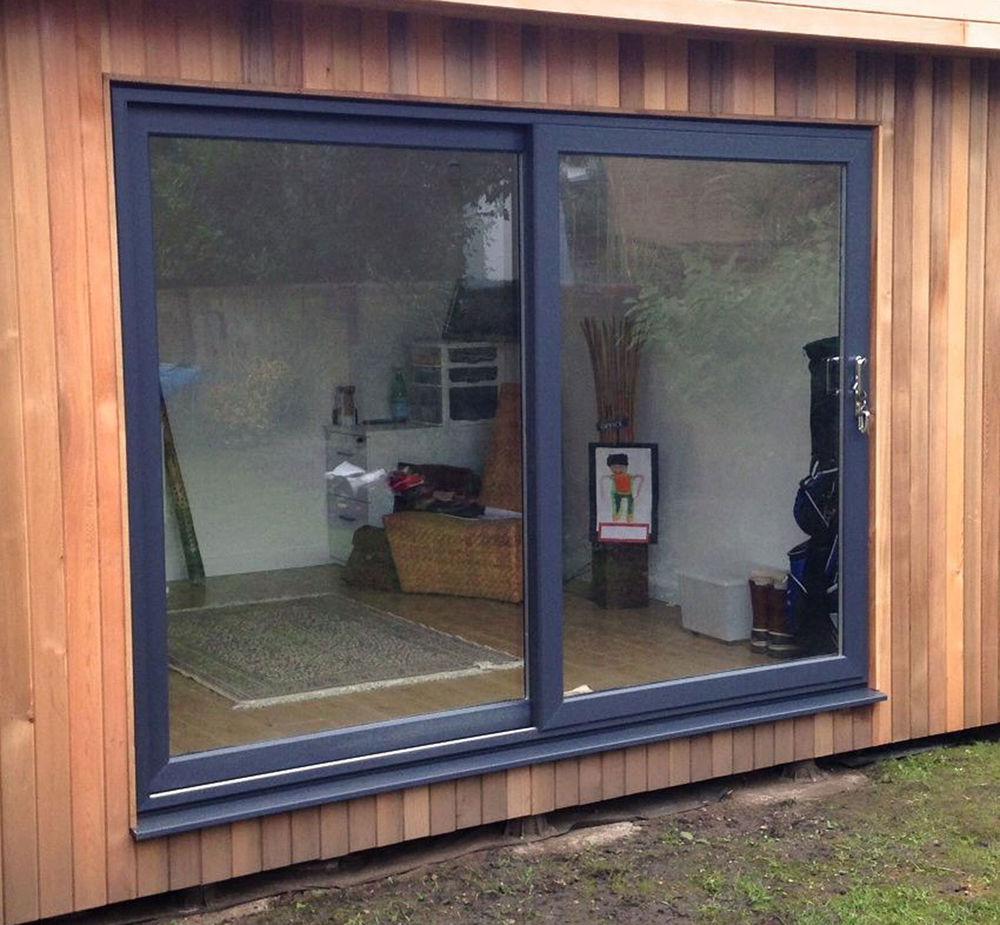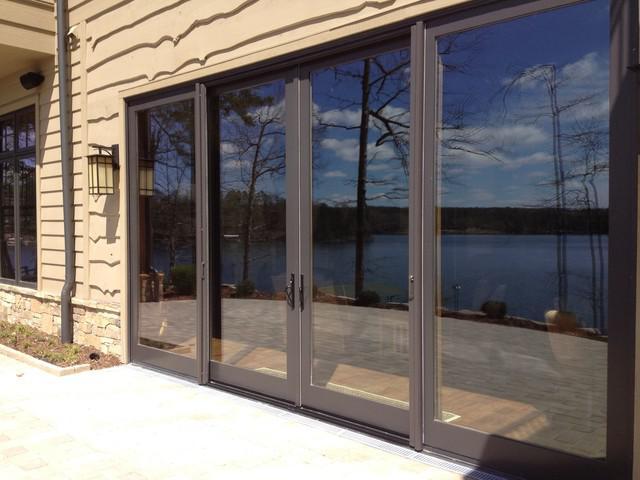The first image is the image on the left, the second image is the image on the right. Given the left and right images, does the statement "One door is open and one is closed." hold true? Answer yes or no. No. The first image is the image on the left, the second image is the image on the right. Considering the images on both sides, is "There are four panes of glass in the sliding glass doors." valid? Answer yes or no. Yes. 